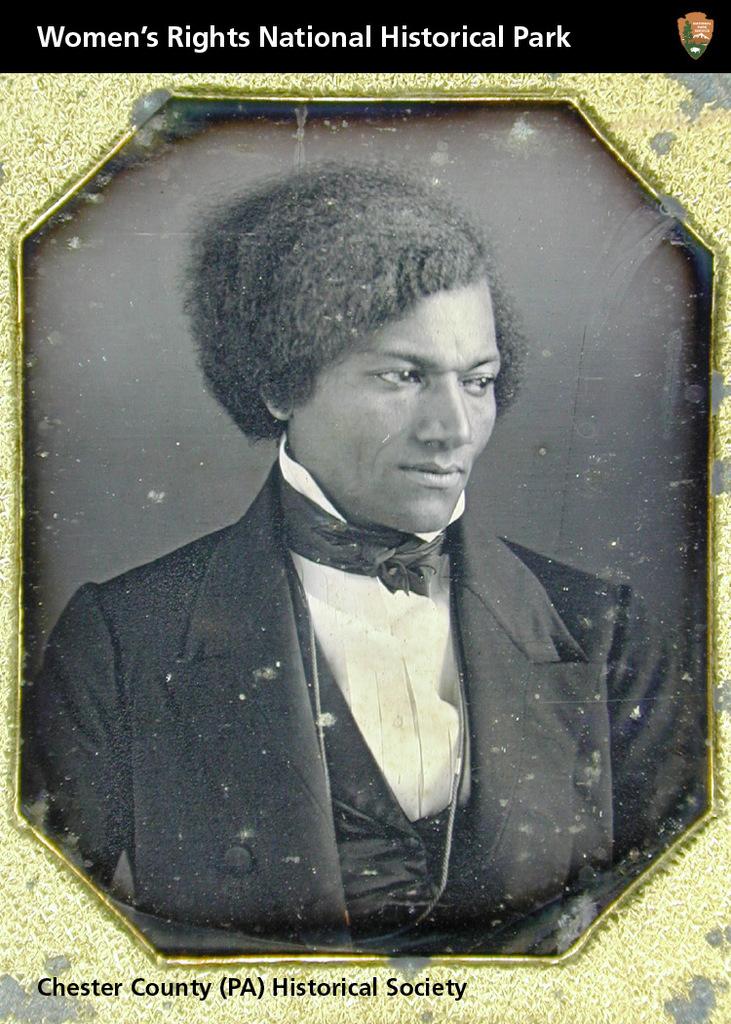What is the name of the historical society?
Make the answer very short. Chester county. What is the name of this national historical park?
Offer a very short reply. Women's rights. 